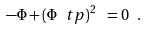Convert formula to latex. <formula><loc_0><loc_0><loc_500><loc_500>- \Phi + ( \Phi ^ { \ } t p ) ^ { 2 } \ = 0 \ .</formula> 